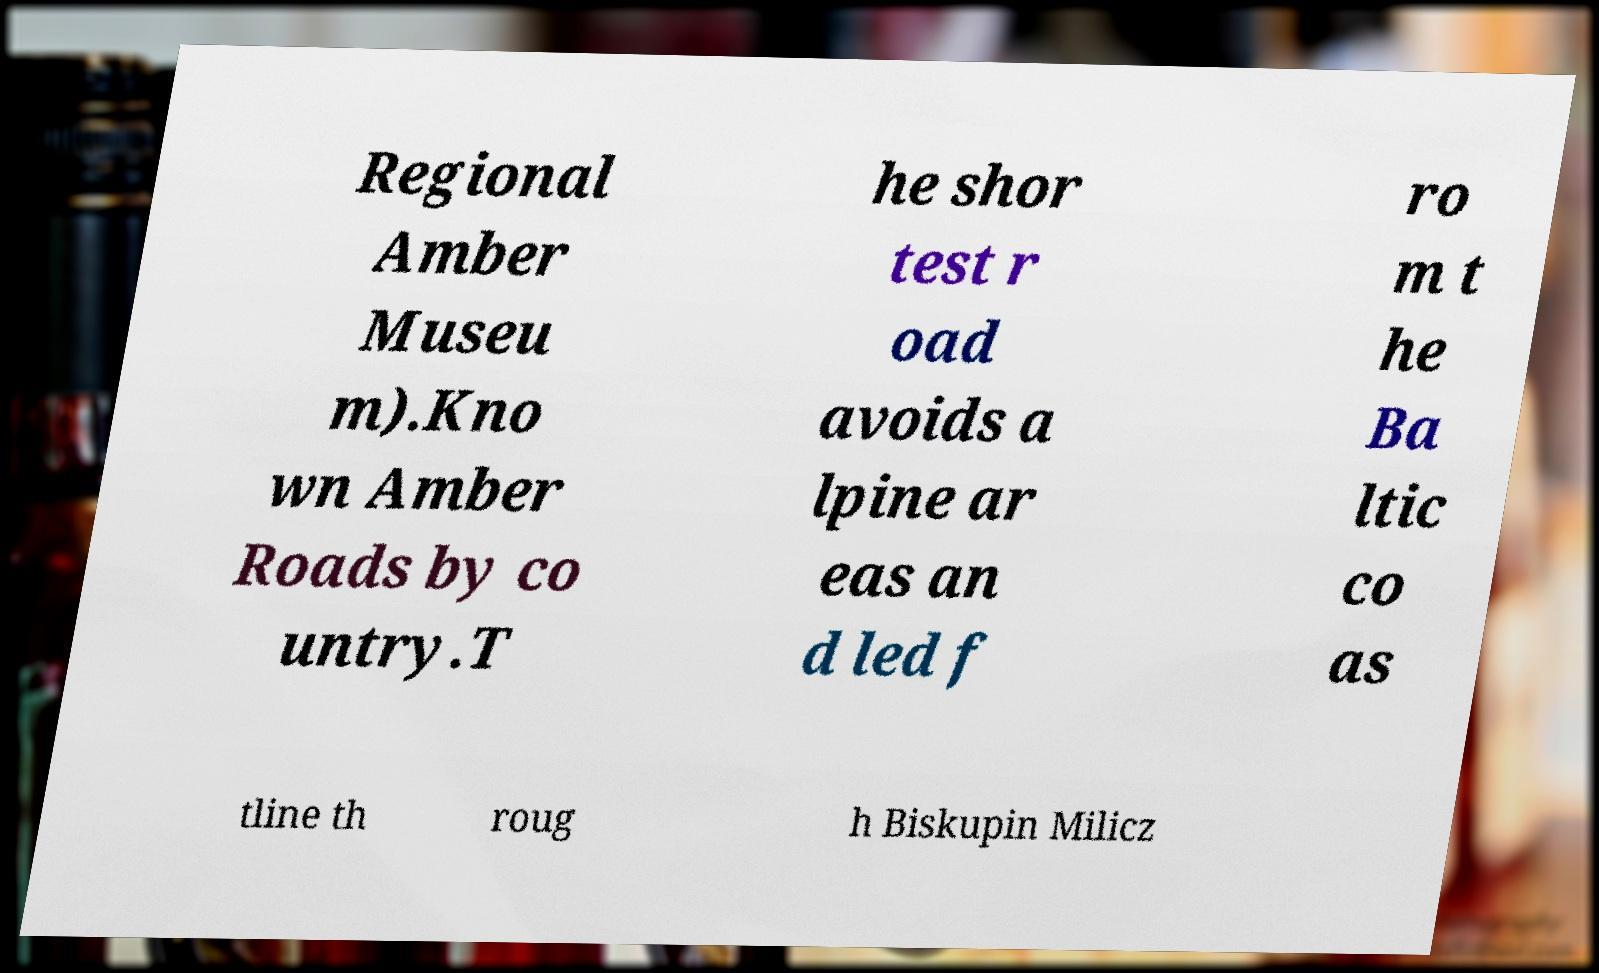What messages or text are displayed in this image? I need them in a readable, typed format. Regional Amber Museu m).Kno wn Amber Roads by co untry.T he shor test r oad avoids a lpine ar eas an d led f ro m t he Ba ltic co as tline th roug h Biskupin Milicz 